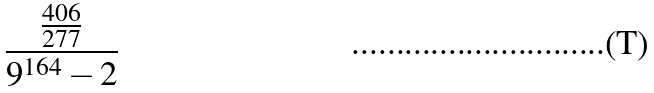Convert formula to latex. <formula><loc_0><loc_0><loc_500><loc_500>\frac { \frac { 4 0 6 } { 2 7 7 } } { 9 ^ { 1 6 4 } - 2 }</formula> 